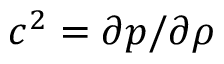Convert formula to latex. <formula><loc_0><loc_0><loc_500><loc_500>c ^ { 2 } = \partial p / \partial \rho</formula> 